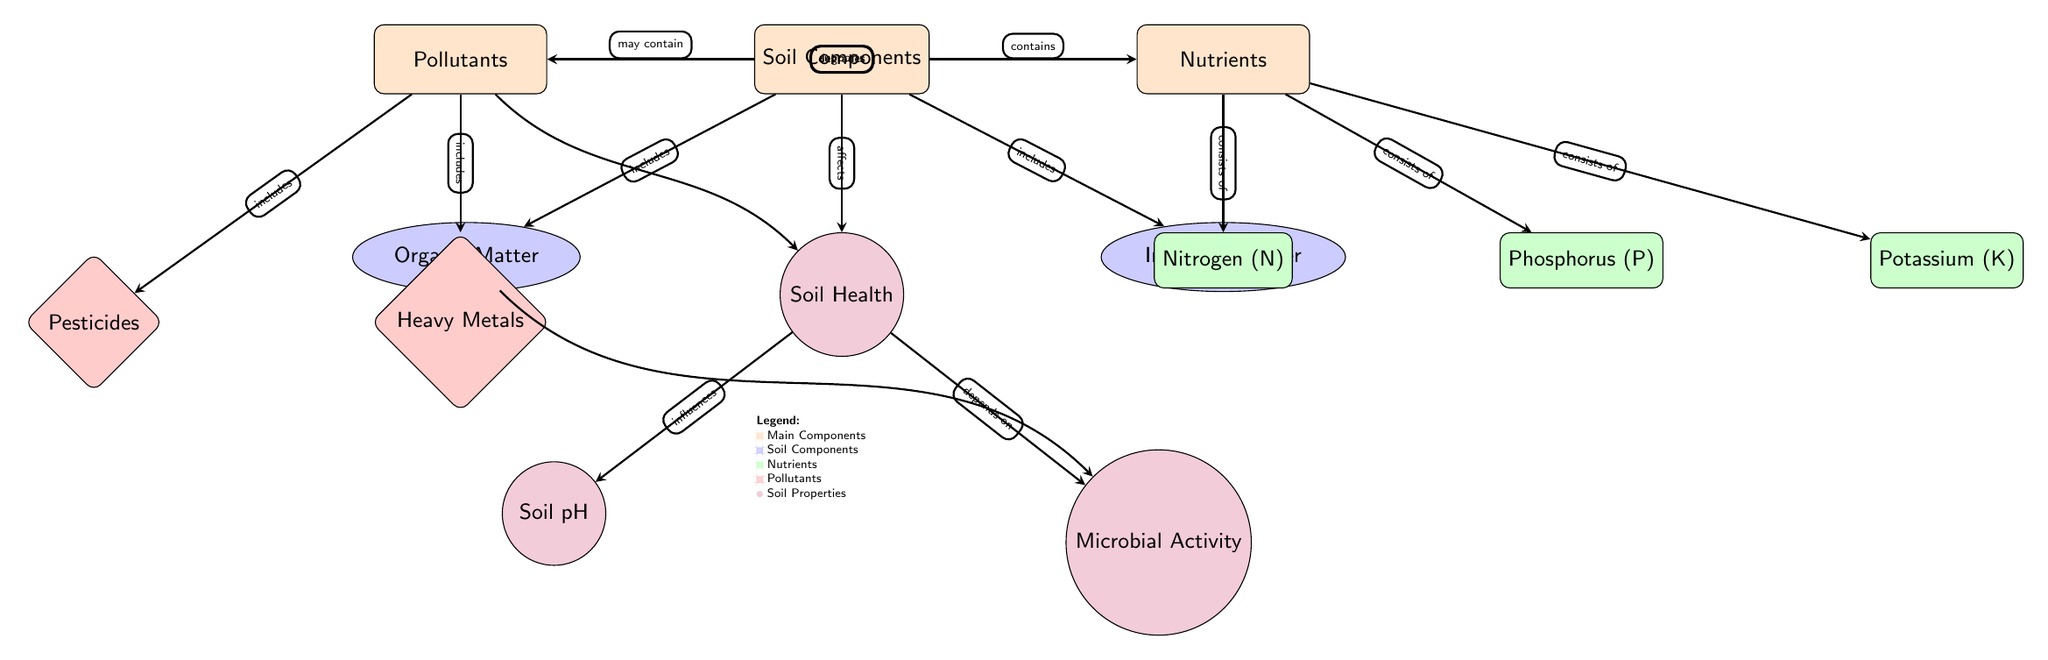What are the two main components of soil? The diagram indicates that the two main components of soil are "Organic Matter" and "Inorganic Matter." These components are directly connected to the "Soil Components" node.
Answer: Organic Matter, Inorganic Matter How many types of nutrients are listed in the diagram? The diagram lists three types of nutrients: Nitrogen (N), Phosphorus (P), and Potassium (K). This can be seen under the "Nutrients" node.
Answer: 3 What effect do pollutants have on soil health? The diagram shows that pollutants "degrade" soil health. This is indicated by the arrow pointing from "Pollutants" to "Soil Health."
Answer: Degrades Which component supports microbial activity? The "Organic Matter" component supports microbial activity, as indicated by the connection and labeling in the diagram.
Answer: Organic Matter What property influences soil pH? According to the diagram, "Soil Health" influences soil pH, which is linked by an arrow from "Soil Health" to "Soil pH."
Answer: Soil Health What includes heavy metals? The diagram states that heavy metals are included under the "Pollutants" node. This is shown by the arrow connecting them.
Answer: Pollutants What does soil structure directly include? The "Soil Components" node directly includes both "Organic Matter" and "Inorganic Matter," as indicated by the arrows directed from "Soil Components" to these nodes.
Answer: Organic Matter, Inorganic Matter Which nutrient component is positioned to the right of Nitrogen? In the diagram, Phosphorus (P) is positioned to the right of Nitrogen (N) under the "Nutrients" category.
Answer: Phosphorus 